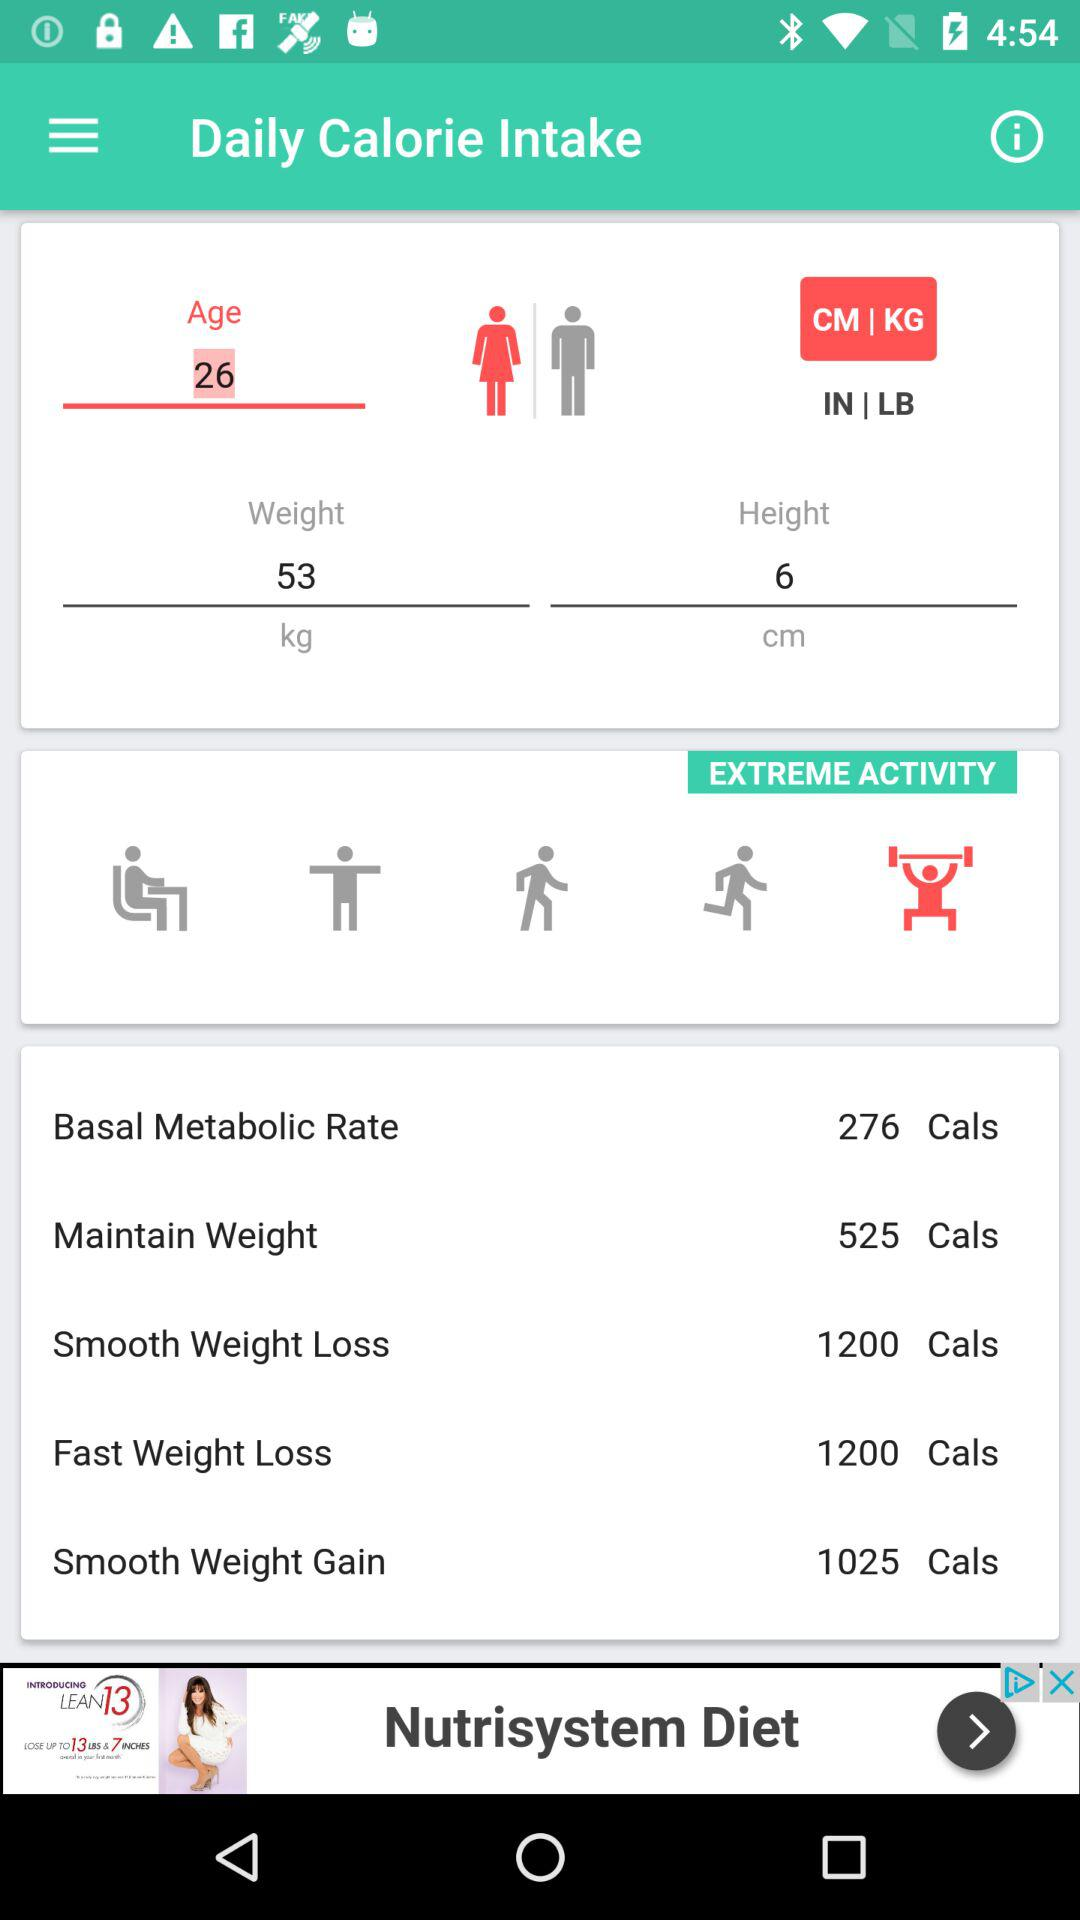What is the height? The height is 6 cm. 